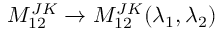Convert formula to latex. <formula><loc_0><loc_0><loc_500><loc_500>M _ { 1 2 } ^ { J K } \rightarrow M _ { 1 2 } ^ { J K } ( \lambda _ { 1 } , \lambda _ { 2 } )</formula> 